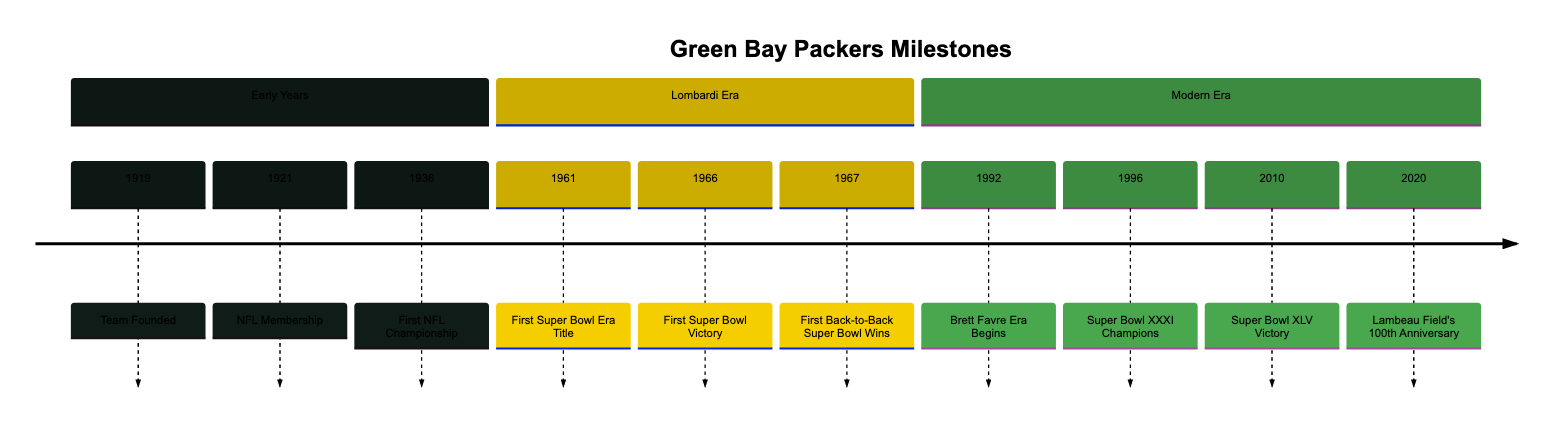What year was the Green Bay Packers founded? The timeline clearly indicates that the Packers were established in the year 1919.
Answer: 1919 What significant event happened in 1966? According to the timeline, the Packers achieved their first Super Bowl victory in 1966 by defeating the Kansas City Chiefs.
Answer: First Super Bowl Victory How many Super Bowl titles did the Packers win by 2010? The timeline shows two Super Bowls won before 2010, which are Super Bowl I in 1966 and Super Bowl II in 1967, in addition to their third title in 1996 and fourth in 2010. Therefore, by 2010, they won four Super Bowl titles.
Answer: 4 What is the time span between the first NFL Championship and the first Super Bowl title? The first NFL Championship was in 1936, and the first Super Bowl title was in 1966. To find the time span, we subtract 1936 from 1966, which gives us 30 years.
Answer: 30 years In which section did the Brett Favre era start? The timeline organizes the events into sections, and the entry for Brett Favre Era starts in the "Modern Era" section.
Answer: Modern Era What milestone occurred in 2020? The timeline indicates that the Packers celebrated Lambeau Field's 100th Anniversary in 2020.
Answer: Lambeau Field's 100th Anniversary How many events are listed in the Lombardi Era section? The Lombardi Era section of the timeline contains three events: First Super Bowl Era Title, First Super Bowl Victory, and First Back-to-Back Super Bowl Wins. Therefore, there are three events listed.
Answer: 3 Which team did the Packers defeat to win their first NFL Championship? The timeline specifically mentions that the Packers defeated the Boston Redskins to win their first NFL Championship in 1936.
Answer: Boston Redskins What event marks the beginning of the Packers' enduring success? The timeline highlights the first Super Bowl era title in 1961 as a turning point that initiated a new era of dominance under coach Vince Lombardi.
Answer: First Super Bowl Era Title 